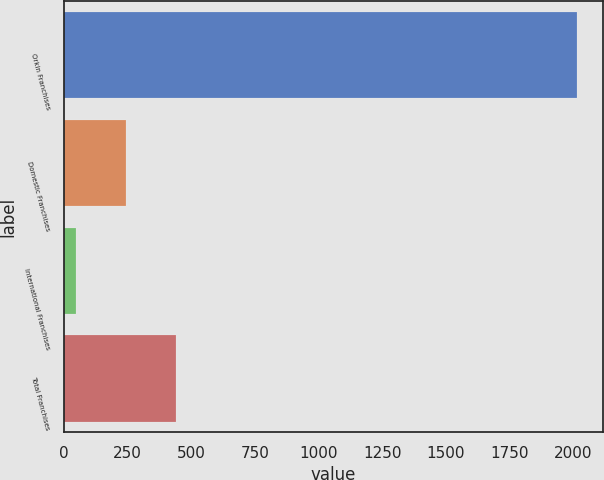<chart> <loc_0><loc_0><loc_500><loc_500><bar_chart><fcel>Orkin Franchises<fcel>Domestic Franchises<fcel>International Franchises<fcel>Total Franchises<nl><fcel>2015<fcel>244.7<fcel>48<fcel>441.4<nl></chart> 